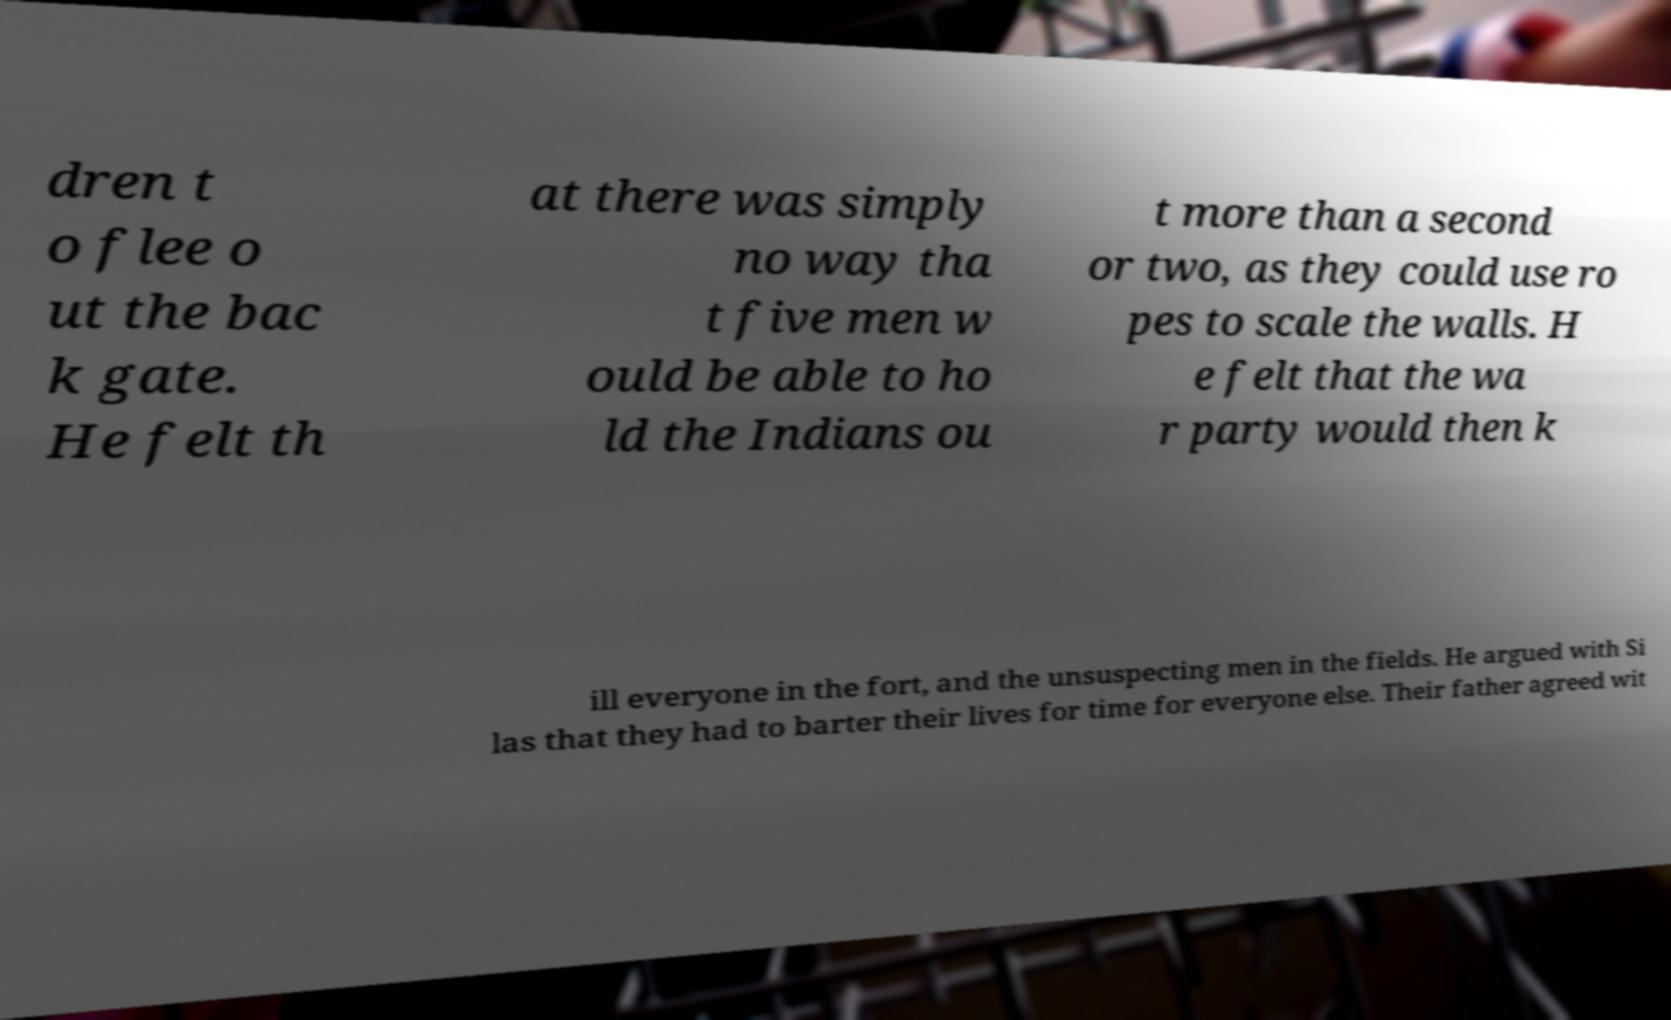What messages or text are displayed in this image? I need them in a readable, typed format. dren t o flee o ut the bac k gate. He felt th at there was simply no way tha t five men w ould be able to ho ld the Indians ou t more than a second or two, as they could use ro pes to scale the walls. H e felt that the wa r party would then k ill everyone in the fort, and the unsuspecting men in the fields. He argued with Si las that they had to barter their lives for time for everyone else. Their father agreed wit 